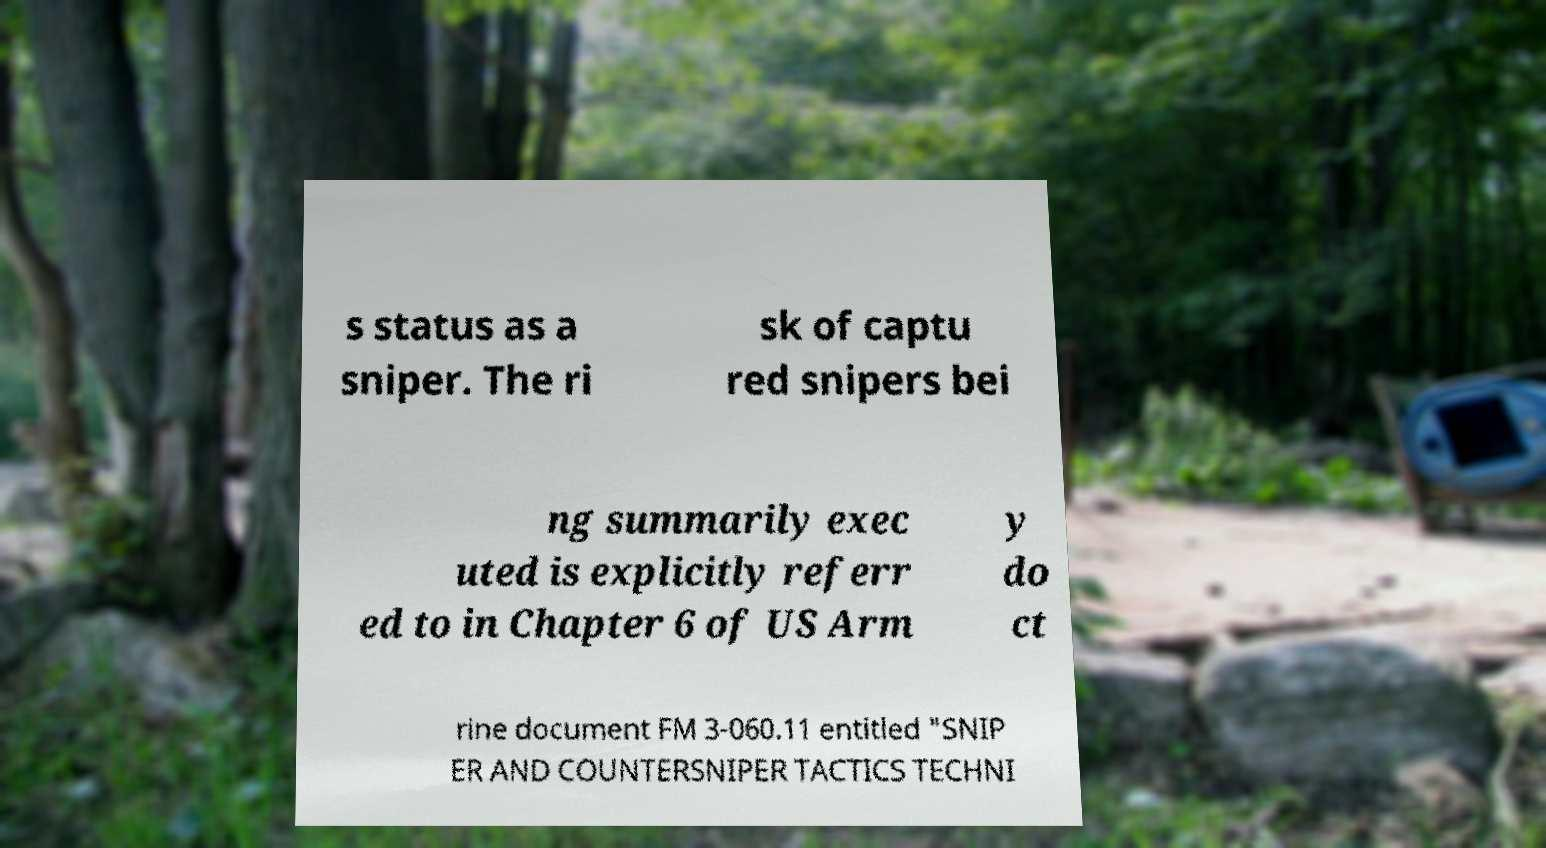There's text embedded in this image that I need extracted. Can you transcribe it verbatim? s status as a sniper. The ri sk of captu red snipers bei ng summarily exec uted is explicitly referr ed to in Chapter 6 of US Arm y do ct rine document FM 3-060.11 entitled "SNIP ER AND COUNTERSNIPER TACTICS TECHNI 